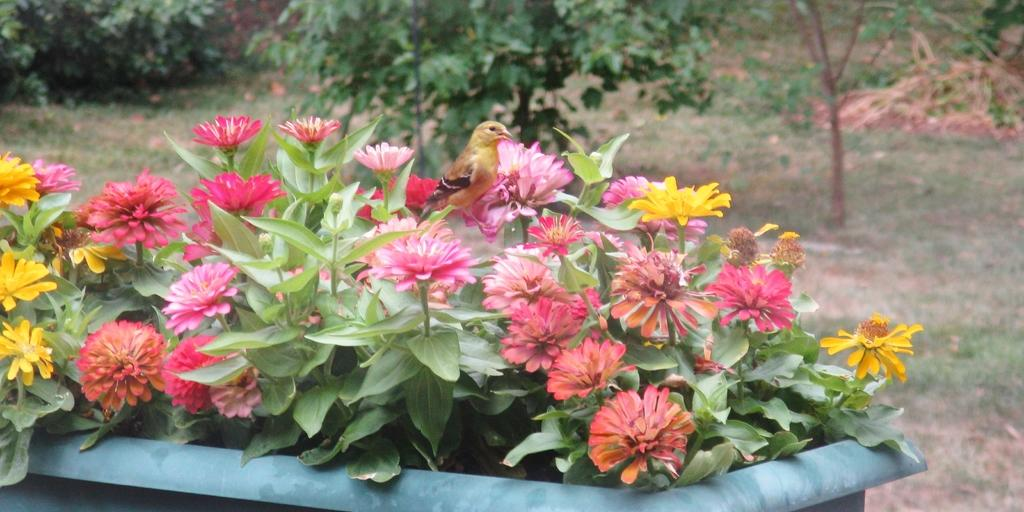What type of plants can be seen in the image? There are flowers in the image. How are the flowers arranged or contained? The flowers are inside a pot. Where is the pot located in the image? The pot is in the center of the image. What can be seen in the background of the image? There are trees in the background of the image. What type of ground is visible in the image? There is grass on the ground in the image. What type of force is being applied to the stone in the image? There is no stone present in the image, so no force can be applied to it. 